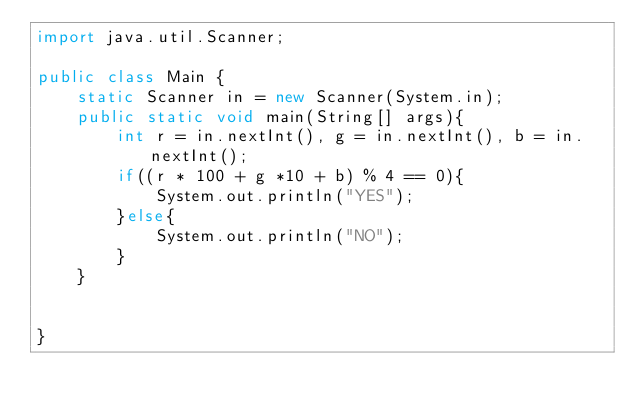<code> <loc_0><loc_0><loc_500><loc_500><_Java_>import java.util.Scanner;

public class Main {
	static Scanner in = new Scanner(System.in);
	public static void main(String[] args){
		int r = in.nextInt(), g = in.nextInt(), b = in.nextInt();
		if((r * 100 + g *10 + b) % 4 == 0){
			System.out.println("YES");
		}else{
			System.out.println("NO");
		}
	}
	

}
</code> 